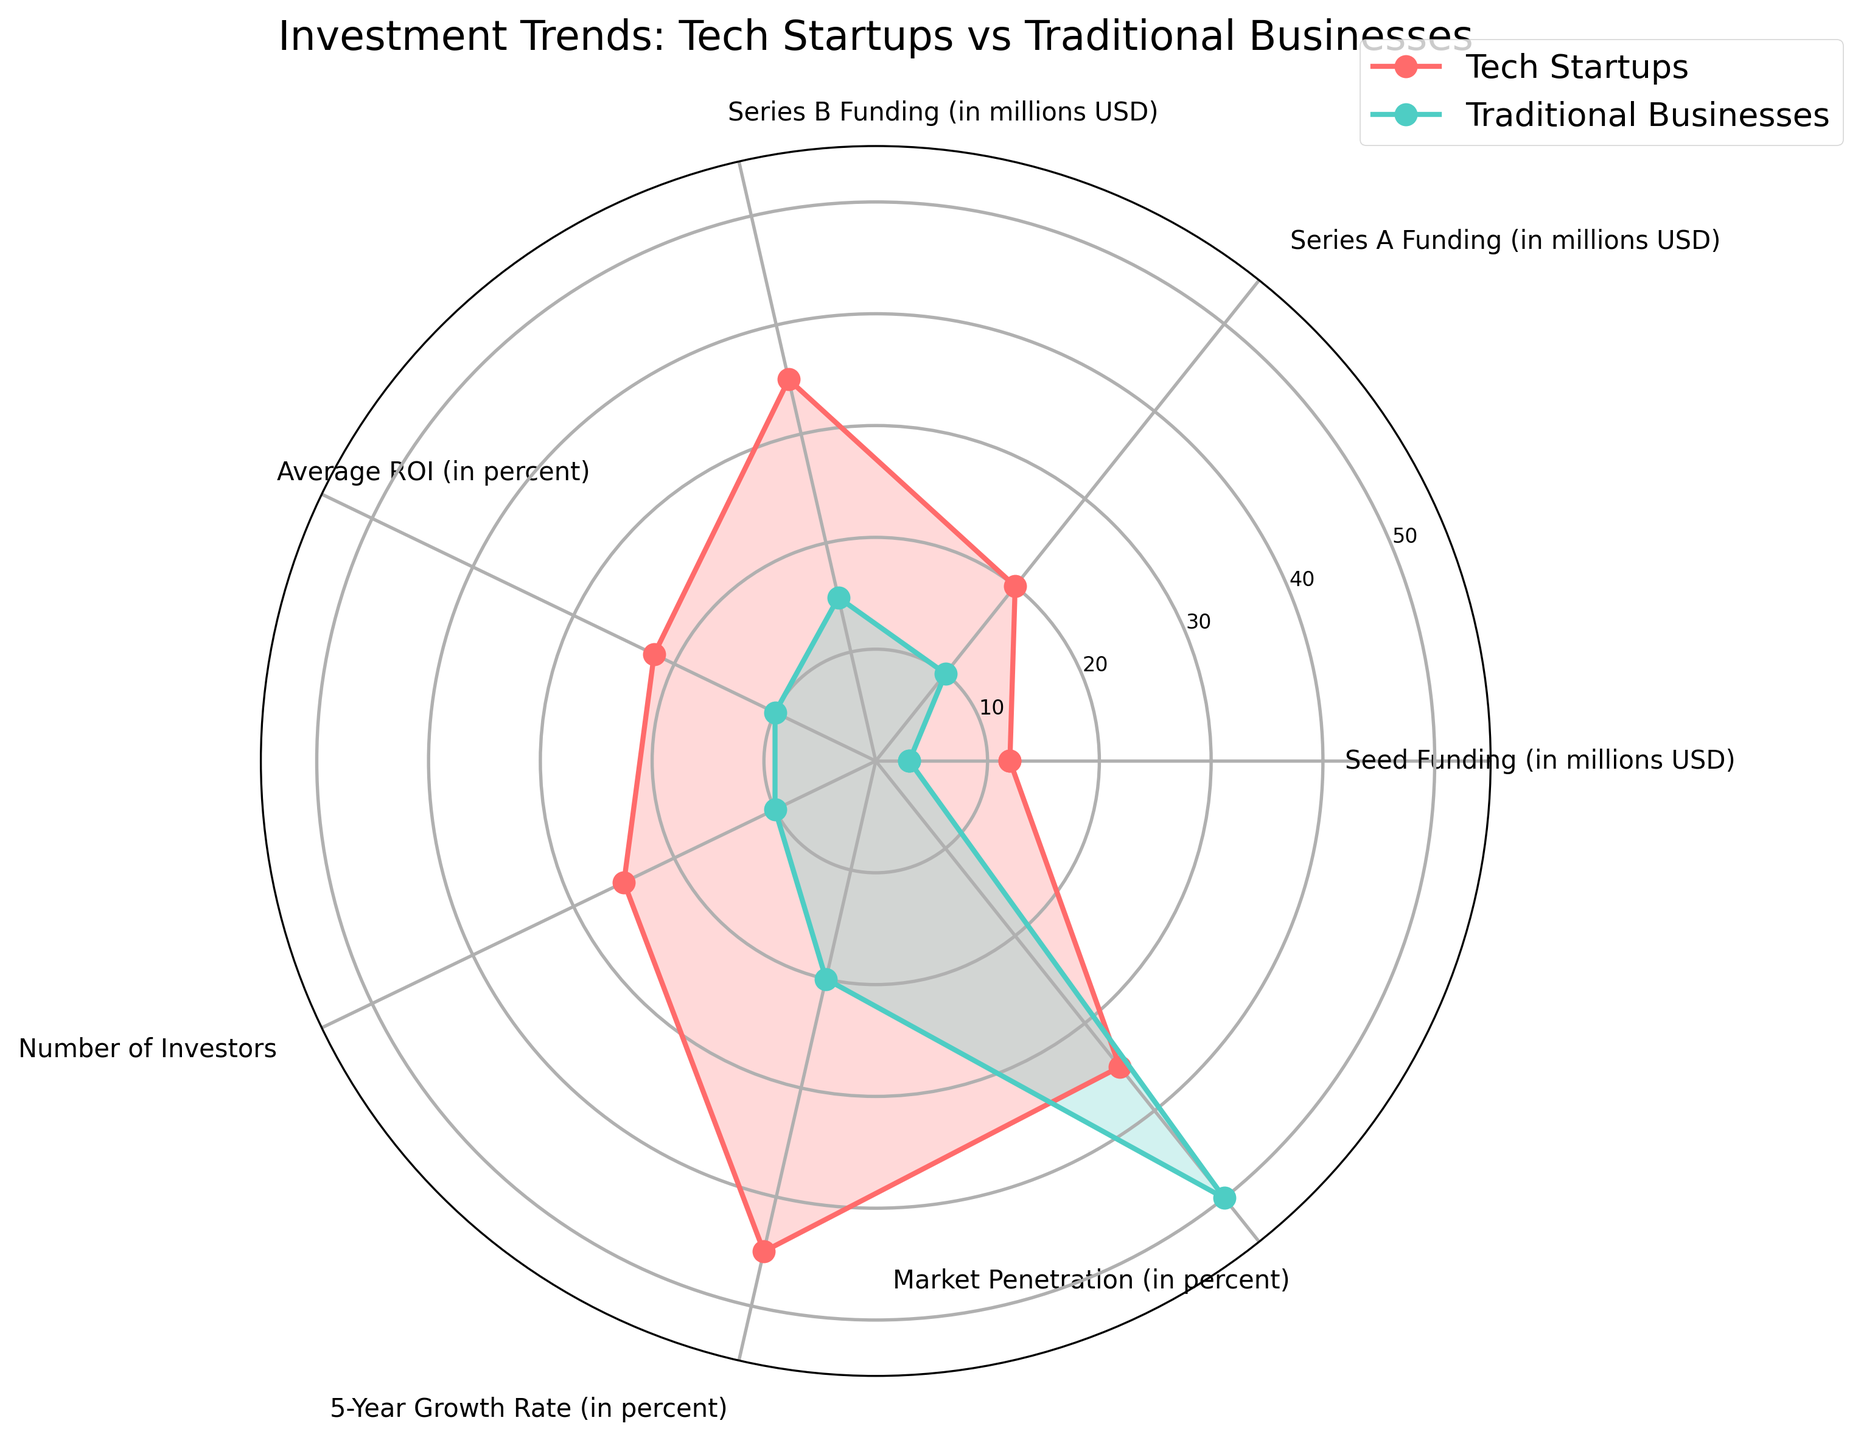What is the title of the radar chart? The title is usually found at the top of the chart, and for this particular radar chart, it is prominently displayed.
Answer: Investment Trends: Tech Startups vs Traditional Businesses Which category has the highest value for Tech Startups? By looking at the line representing Tech Startups, we can see that the "5-Year Growth Rate" has the highest value.
Answer: 5-Year Growth Rate How many data points are there for each group on the radar chart? The radar chart shows data points for several categories, each representing a different metric. There are 7 categories shown in the data.
Answer: 7 In which category do Traditional Businesses outperform Tech Startups? By comparing the values for both groups across categories, it is clear that Traditional Businesses have higher values in "Market Penetration."
Answer: Market Penetration What's the average funding (Seed, Series A, and Series B) for Tech Startups? To find this, sum the funding values (12 + 20 + 35) and divide by 3: (12+20+35)/3 = 67/3.
Answer: 22.33 million USD How much higher is the number of investors for Tech Startups compared to Traditional Businesses? Subtract the number of investors for Traditional Businesses from the number for Tech Startups: 25 - 10 = 15.
Answer: 15 Which group has a higher 5-Year Growth Rate? The chart shows Tech Startups at 45% and Traditional Businesses at 20% for the 5-Year Growth Rate, making Tech Startups higher.
Answer: Tech Startups What is the difference in Average ROI between Tech Startups and Traditional Businesses? Subtract the Average ROI for Traditional Businesses from that for Tech Startups: 22% - 10% = 12%.
Answer: 12% Which funding category shows the smallest difference between Tech Startups and Traditional Businesses? By comparing the differences in funding categories, the smallest difference is in "Series A Funding": 20 - 10 = 10 million USD.
Answer: Series A Funding What trend can you observe from comparing Market Penetration between the two groups? Traditional Businesses have a significantly higher market penetration compared to Tech Startups, which implies they are more established in the market.
Answer: Traditional Businesses have higher market penetration 